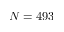<formula> <loc_0><loc_0><loc_500><loc_500>N = 4 9 3</formula> 